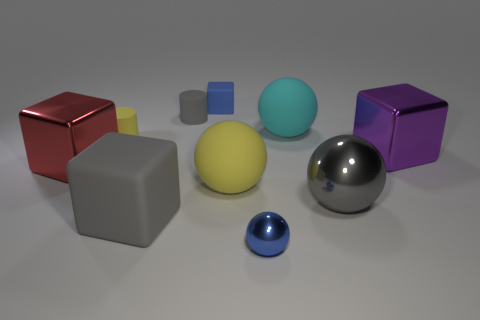Subtract all cylinders. How many objects are left? 8 Add 7 large yellow things. How many large yellow things are left? 8 Add 3 green objects. How many green objects exist? 3 Subtract 0 cyan cubes. How many objects are left? 10 Subtract all small cyan metallic cylinders. Subtract all yellow matte cylinders. How many objects are left? 9 